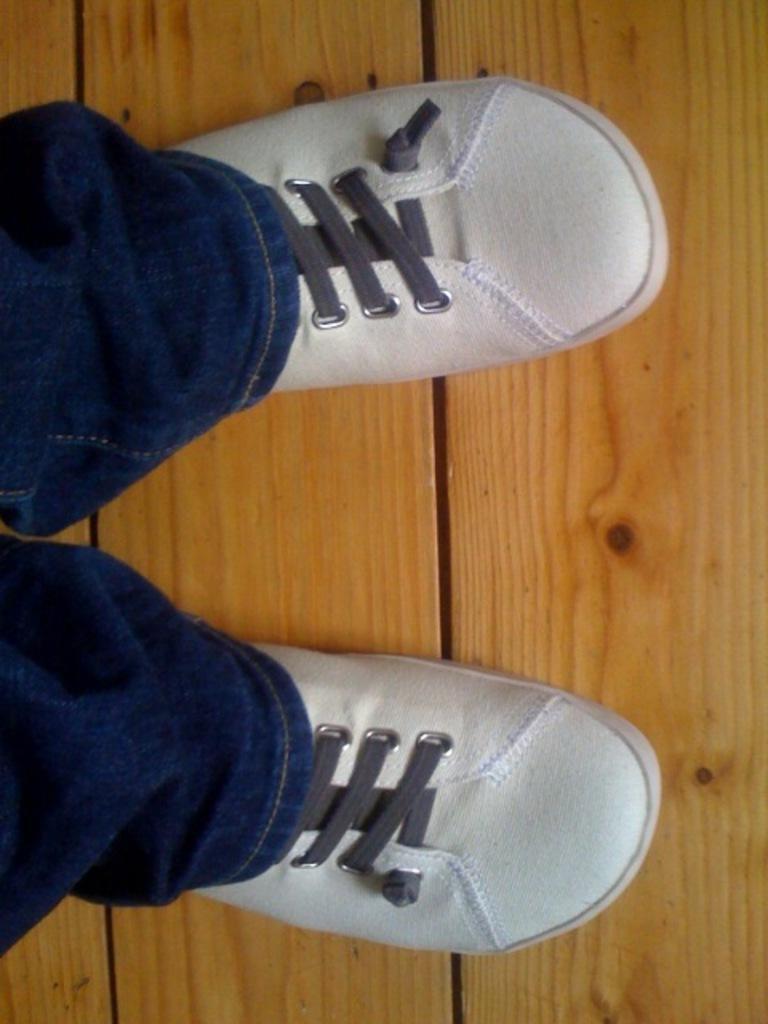In one or two sentences, can you explain what this image depicts? There is a person in jean pant, wearing white color shoes on the wooden surface. 